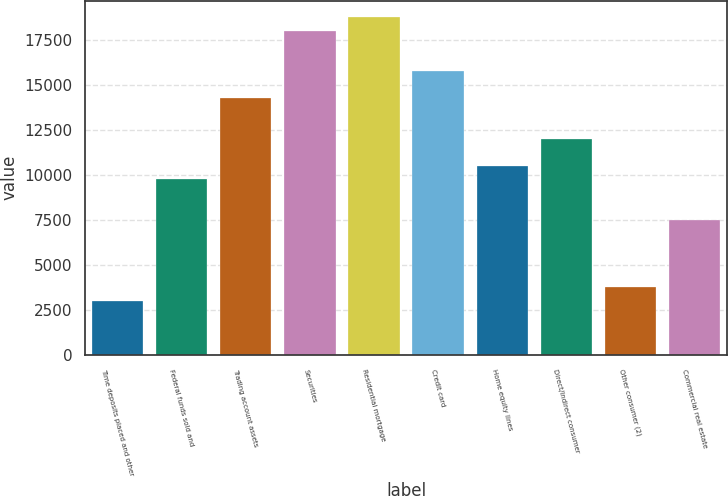<chart> <loc_0><loc_0><loc_500><loc_500><bar_chart><fcel>Time deposits placed and other<fcel>Federal funds sold and<fcel>Trading account assets<fcel>Securities<fcel>Residential mortgage<fcel>Credit card<fcel>Home equity lines<fcel>Direct/Indirect consumer<fcel>Other consumer (2)<fcel>Commercial real estate<nl><fcel>3020<fcel>9765.5<fcel>14262.5<fcel>18010<fcel>18759.5<fcel>15761.5<fcel>10515<fcel>12014<fcel>3769.5<fcel>7517<nl></chart> 